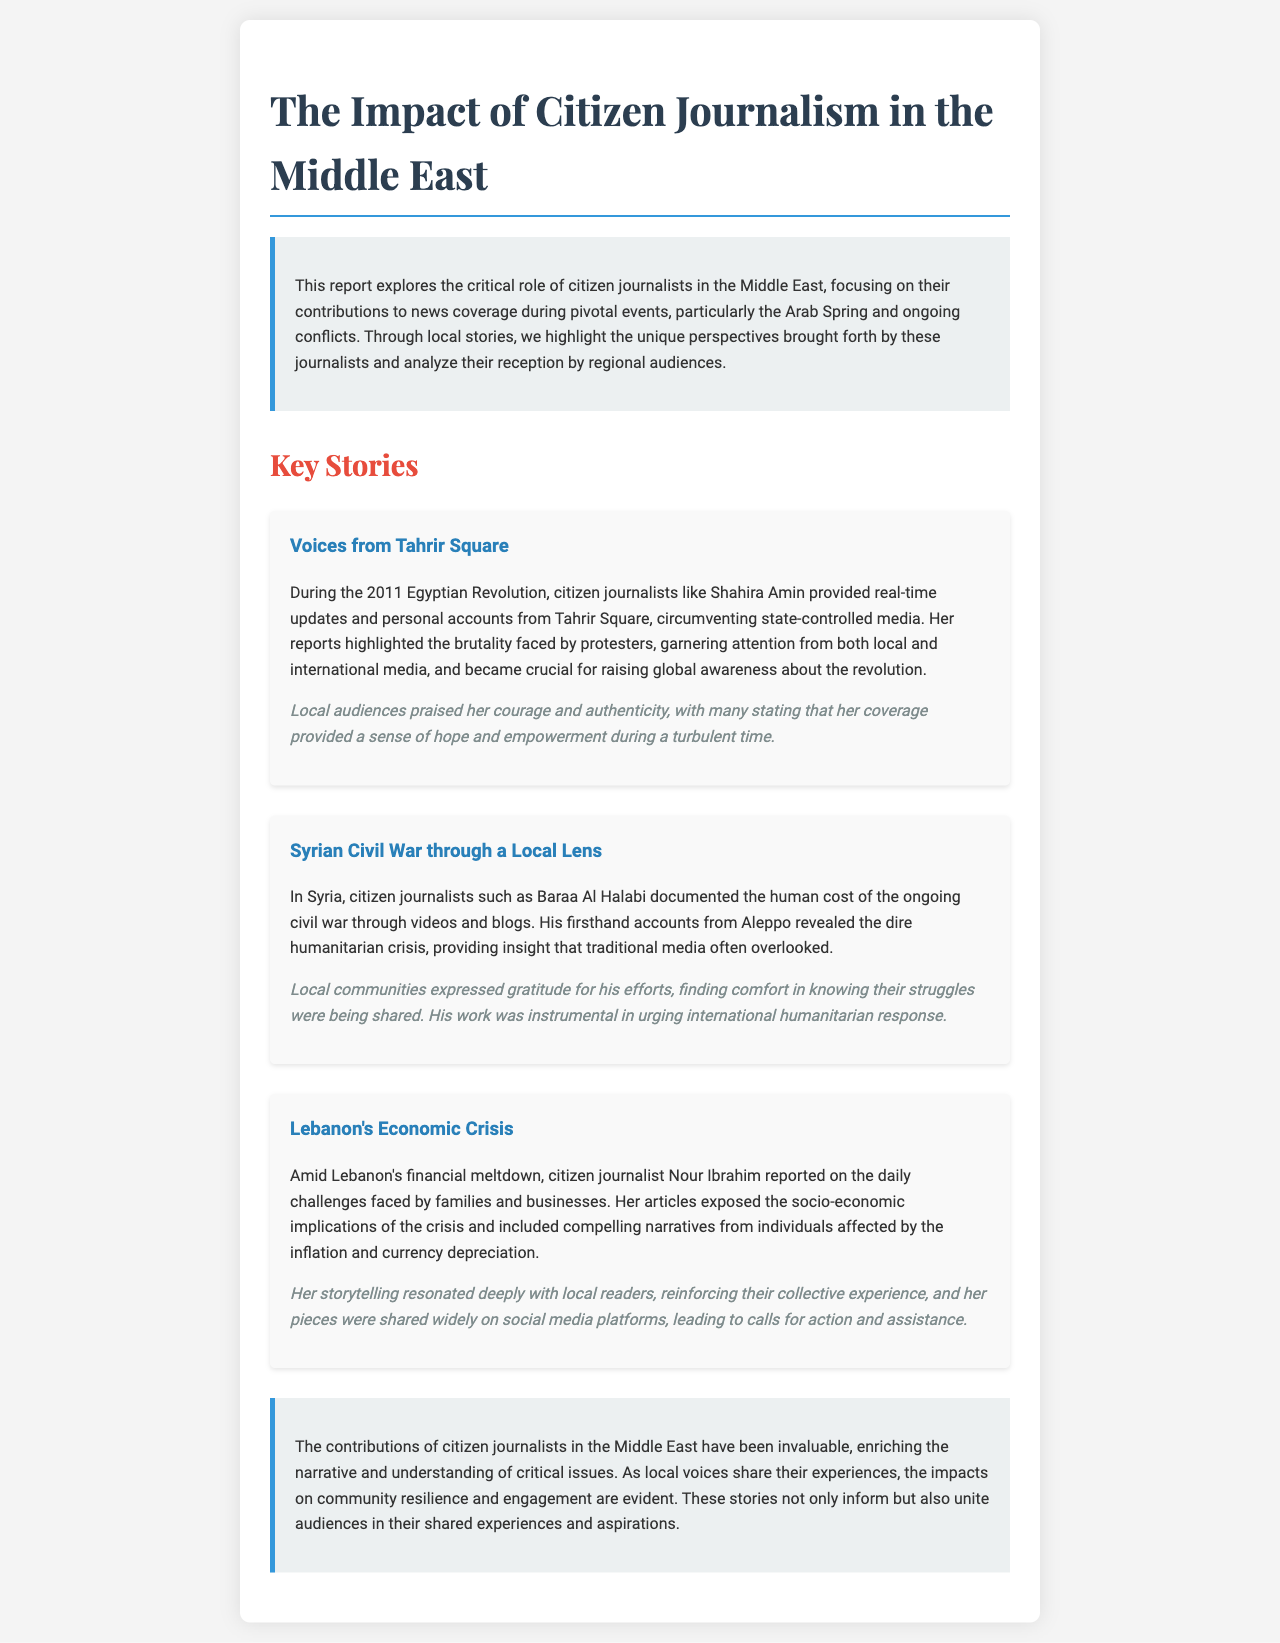What is the title of the report? The title of the report is explicitly stated at the beginning of the document.
Answer: The Impact of Citizen Journalism in the Middle East Who documented the human cost of the Syrian Civil War? This information is found in the section discussing the Syrian Civil War specifically.
Answer: Baraa Al Halabi What year did the Egyptian Revolution take place? The document mentions the year in the context of the events surrounding Tahrir Square.
Answer: 2011 Which city did Baraa Al Halabi document from? This detail is provided in the section discussing his work during the Syrian Civil War.
Answer: Aleppo What was the primary focus of Nour Ibrahim's reporting? This question addresses the subject matter of Nour Ibrahim's articles as outlined in the document.
Answer: Daily challenges faced by families and businesses What sentiment did local audiences express towards Shahira Amin's coverage? This is described under the reception of Shahira Amin's reports from Tahrir Square.
Answer: Courage and authenticity What was a significant impact of citizen journalism according to the conclusion? The conclusion summarizes key impacts mentioned throughout the document.
Answer: Community resilience How were Nour Ibrahim's pieces disseminated widely? The document details how Nour Ibrahim's work reached a broader audience.
Answer: Social media platforms What crucial role did citizen journalists play during the Arab Spring? This information summarizes the overall impact of citizen journalism as discussed in the introduction.
Answer: Contributions to news coverage 